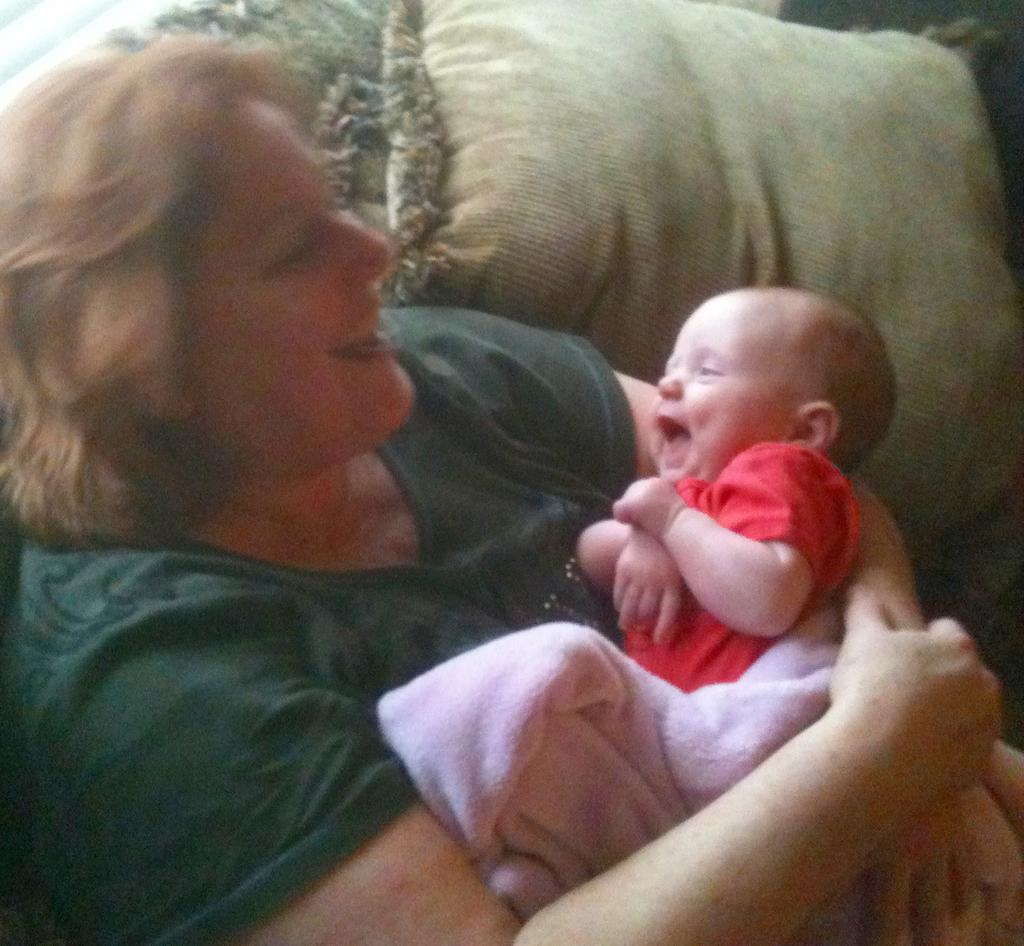Who is the main subject in the image? There is a woman in the image. What is the woman doing in the image? The woman is carrying a baby. What are the woman and the baby wearing? The woman and the baby are wearing clothes. What can be seen in the background of the image? There is a pillow visible in the image. What type of behavior does the baby exhibit towards the pillow in the image? There is no indication of the baby's behavior towards the pillow in the image, as the focus is on the woman carrying the baby. 